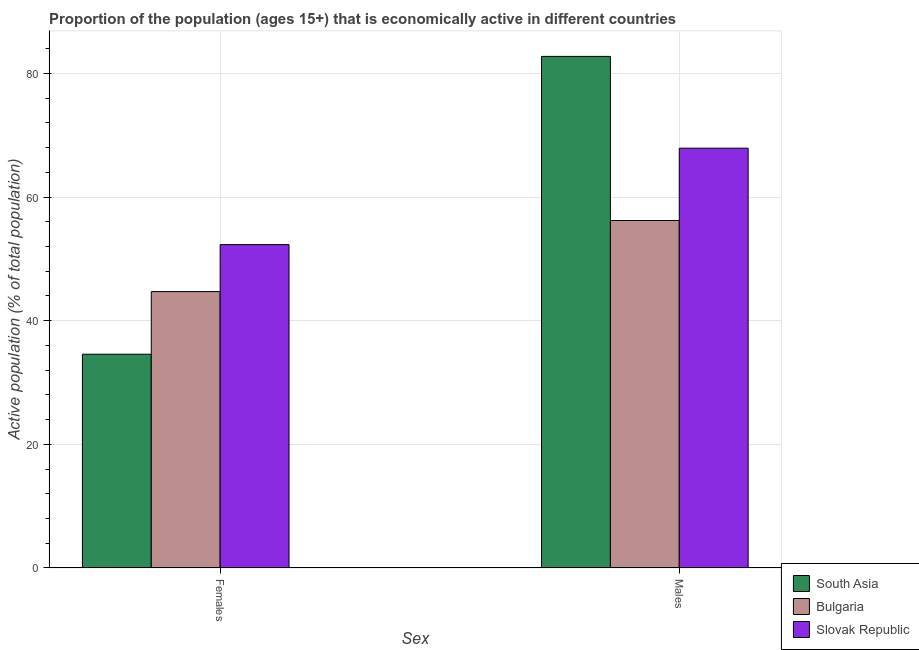How many different coloured bars are there?
Your answer should be very brief. 3. Are the number of bars per tick equal to the number of legend labels?
Your answer should be very brief. Yes. Are the number of bars on each tick of the X-axis equal?
Keep it short and to the point. Yes. How many bars are there on the 2nd tick from the left?
Offer a terse response. 3. What is the label of the 2nd group of bars from the left?
Your answer should be compact. Males. What is the percentage of economically active female population in South Asia?
Your answer should be compact. 34.57. Across all countries, what is the maximum percentage of economically active male population?
Give a very brief answer. 82.74. Across all countries, what is the minimum percentage of economically active male population?
Your answer should be very brief. 56.2. What is the total percentage of economically active female population in the graph?
Your response must be concise. 131.57. What is the difference between the percentage of economically active male population in Bulgaria and that in Slovak Republic?
Your response must be concise. -11.7. What is the difference between the percentage of economically active male population in South Asia and the percentage of economically active female population in Bulgaria?
Offer a terse response. 38.04. What is the average percentage of economically active female population per country?
Ensure brevity in your answer.  43.86. What is the difference between the percentage of economically active female population and percentage of economically active male population in South Asia?
Offer a terse response. -48.17. In how many countries, is the percentage of economically active female population greater than 12 %?
Your answer should be very brief. 3. What is the ratio of the percentage of economically active male population in Slovak Republic to that in South Asia?
Keep it short and to the point. 0.82. Is the percentage of economically active female population in Bulgaria less than that in South Asia?
Make the answer very short. No. What does the 2nd bar from the left in Females represents?
Keep it short and to the point. Bulgaria. How many bars are there?
Provide a short and direct response. 6. Are all the bars in the graph horizontal?
Ensure brevity in your answer.  No. How many countries are there in the graph?
Offer a very short reply. 3. Are the values on the major ticks of Y-axis written in scientific E-notation?
Make the answer very short. No. Does the graph contain any zero values?
Give a very brief answer. No. Does the graph contain grids?
Provide a succinct answer. Yes. Where does the legend appear in the graph?
Your response must be concise. Bottom right. How many legend labels are there?
Make the answer very short. 3. How are the legend labels stacked?
Your answer should be very brief. Vertical. What is the title of the graph?
Give a very brief answer. Proportion of the population (ages 15+) that is economically active in different countries. Does "Poland" appear as one of the legend labels in the graph?
Your answer should be compact. No. What is the label or title of the X-axis?
Keep it short and to the point. Sex. What is the label or title of the Y-axis?
Give a very brief answer. Active population (% of total population). What is the Active population (% of total population) in South Asia in Females?
Make the answer very short. 34.57. What is the Active population (% of total population) in Bulgaria in Females?
Your answer should be very brief. 44.7. What is the Active population (% of total population) of Slovak Republic in Females?
Provide a succinct answer. 52.3. What is the Active population (% of total population) of South Asia in Males?
Make the answer very short. 82.74. What is the Active population (% of total population) of Bulgaria in Males?
Your response must be concise. 56.2. What is the Active population (% of total population) of Slovak Republic in Males?
Your response must be concise. 67.9. Across all Sex, what is the maximum Active population (% of total population) of South Asia?
Offer a terse response. 82.74. Across all Sex, what is the maximum Active population (% of total population) in Bulgaria?
Offer a terse response. 56.2. Across all Sex, what is the maximum Active population (% of total population) in Slovak Republic?
Your response must be concise. 67.9. Across all Sex, what is the minimum Active population (% of total population) of South Asia?
Your response must be concise. 34.57. Across all Sex, what is the minimum Active population (% of total population) of Bulgaria?
Your answer should be compact. 44.7. Across all Sex, what is the minimum Active population (% of total population) of Slovak Republic?
Make the answer very short. 52.3. What is the total Active population (% of total population) in South Asia in the graph?
Ensure brevity in your answer.  117.31. What is the total Active population (% of total population) in Bulgaria in the graph?
Your answer should be very brief. 100.9. What is the total Active population (% of total population) in Slovak Republic in the graph?
Your answer should be compact. 120.2. What is the difference between the Active population (% of total population) of South Asia in Females and that in Males?
Your response must be concise. -48.17. What is the difference between the Active population (% of total population) in Slovak Republic in Females and that in Males?
Your response must be concise. -15.6. What is the difference between the Active population (% of total population) in South Asia in Females and the Active population (% of total population) in Bulgaria in Males?
Keep it short and to the point. -21.63. What is the difference between the Active population (% of total population) of South Asia in Females and the Active population (% of total population) of Slovak Republic in Males?
Give a very brief answer. -33.33. What is the difference between the Active population (% of total population) in Bulgaria in Females and the Active population (% of total population) in Slovak Republic in Males?
Your answer should be compact. -23.2. What is the average Active population (% of total population) of South Asia per Sex?
Your answer should be compact. 58.66. What is the average Active population (% of total population) of Bulgaria per Sex?
Your answer should be compact. 50.45. What is the average Active population (% of total population) in Slovak Republic per Sex?
Offer a very short reply. 60.1. What is the difference between the Active population (% of total population) in South Asia and Active population (% of total population) in Bulgaria in Females?
Make the answer very short. -10.13. What is the difference between the Active population (% of total population) in South Asia and Active population (% of total population) in Slovak Republic in Females?
Your answer should be compact. -17.73. What is the difference between the Active population (% of total population) in Bulgaria and Active population (% of total population) in Slovak Republic in Females?
Your answer should be compact. -7.6. What is the difference between the Active population (% of total population) of South Asia and Active population (% of total population) of Bulgaria in Males?
Offer a terse response. 26.54. What is the difference between the Active population (% of total population) in South Asia and Active population (% of total population) in Slovak Republic in Males?
Your response must be concise. 14.84. What is the ratio of the Active population (% of total population) of South Asia in Females to that in Males?
Provide a succinct answer. 0.42. What is the ratio of the Active population (% of total population) of Bulgaria in Females to that in Males?
Make the answer very short. 0.8. What is the ratio of the Active population (% of total population) in Slovak Republic in Females to that in Males?
Ensure brevity in your answer.  0.77. What is the difference between the highest and the second highest Active population (% of total population) in South Asia?
Provide a succinct answer. 48.17. What is the difference between the highest and the second highest Active population (% of total population) in Bulgaria?
Your answer should be very brief. 11.5. What is the difference between the highest and the lowest Active population (% of total population) in South Asia?
Your answer should be very brief. 48.17. What is the difference between the highest and the lowest Active population (% of total population) of Bulgaria?
Offer a terse response. 11.5. What is the difference between the highest and the lowest Active population (% of total population) in Slovak Republic?
Ensure brevity in your answer.  15.6. 